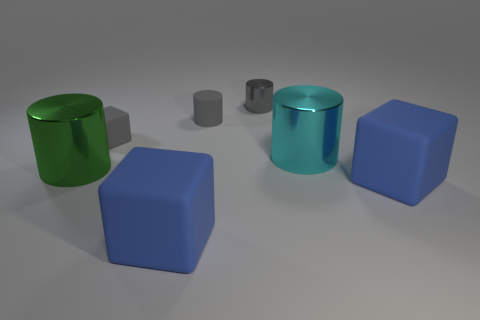Are there more gray shiny things than gray cylinders?
Keep it short and to the point. No. Does the gray cube have the same size as the green shiny cylinder?
Ensure brevity in your answer.  No. What number of objects are either small red spheres or metal cylinders?
Your answer should be very brief. 3. What shape is the gray object that is to the right of the rubber cylinder that is behind the gray cube to the left of the tiny gray matte cylinder?
Your answer should be very brief. Cylinder. Does the large cylinder that is to the right of the large green cylinder have the same material as the blue cube that is to the right of the cyan shiny cylinder?
Your response must be concise. No. There is a large cyan object that is the same shape as the tiny gray metal object; what is its material?
Your answer should be very brief. Metal. Is there anything else that has the same size as the gray rubber cylinder?
Keep it short and to the point. Yes. Does the large blue matte thing that is left of the cyan thing have the same shape as the metallic thing that is to the left of the tiny rubber cube?
Offer a very short reply. No. Is the number of tiny gray metallic cylinders on the left side of the tiny gray shiny object less than the number of tiny gray cubes on the right side of the cyan shiny thing?
Your response must be concise. No. How many other things are there of the same shape as the green metallic thing?
Offer a terse response. 3. 